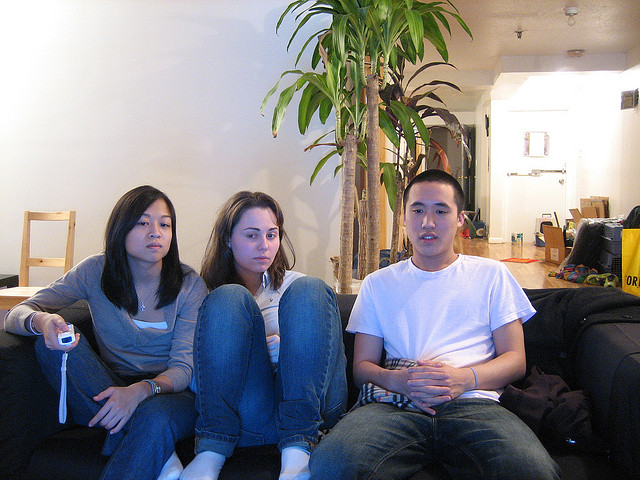Identify the text displayed in this image. OR 